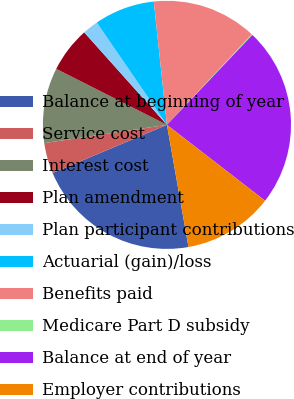Convert chart to OTSL. <chart><loc_0><loc_0><loc_500><loc_500><pie_chart><fcel>Balance at beginning of year<fcel>Service cost<fcel>Interest cost<fcel>Plan amendment<fcel>Plan participant contributions<fcel>Actuarial (gain)/loss<fcel>Benefits paid<fcel>Medicare Part D subsidy<fcel>Balance at end of year<fcel>Employer contributions<nl><fcel>21.44%<fcel>3.99%<fcel>9.81%<fcel>5.93%<fcel>2.05%<fcel>7.87%<fcel>13.68%<fcel>0.11%<fcel>23.38%<fcel>11.75%<nl></chart> 